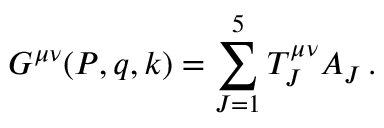Convert formula to latex. <formula><loc_0><loc_0><loc_500><loc_500>G ^ { \mu \nu } ( P , q , k ) = \sum _ { J = 1 } ^ { 5 } T _ { J } ^ { \mu \nu } A _ { J } \, .</formula> 